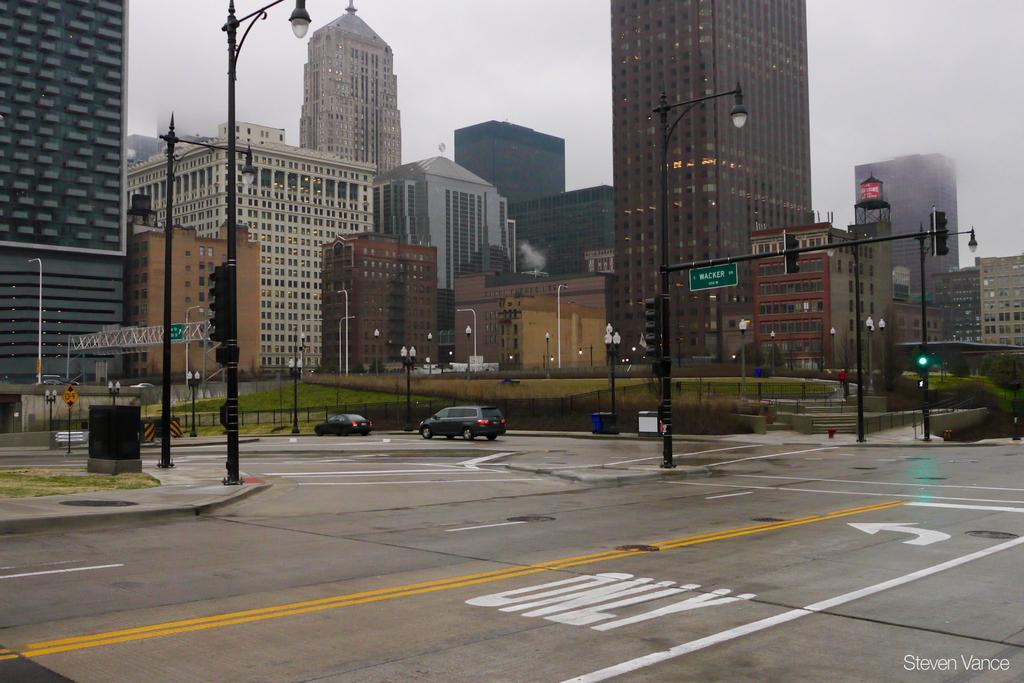Please provide a concise description of this image. In this image there is a road at bottom of this image and there are some vehicles in middle of this image and there are some buildings in the background and there is a sky at top of this image. there are some current polls as we can see in middle of this image. 